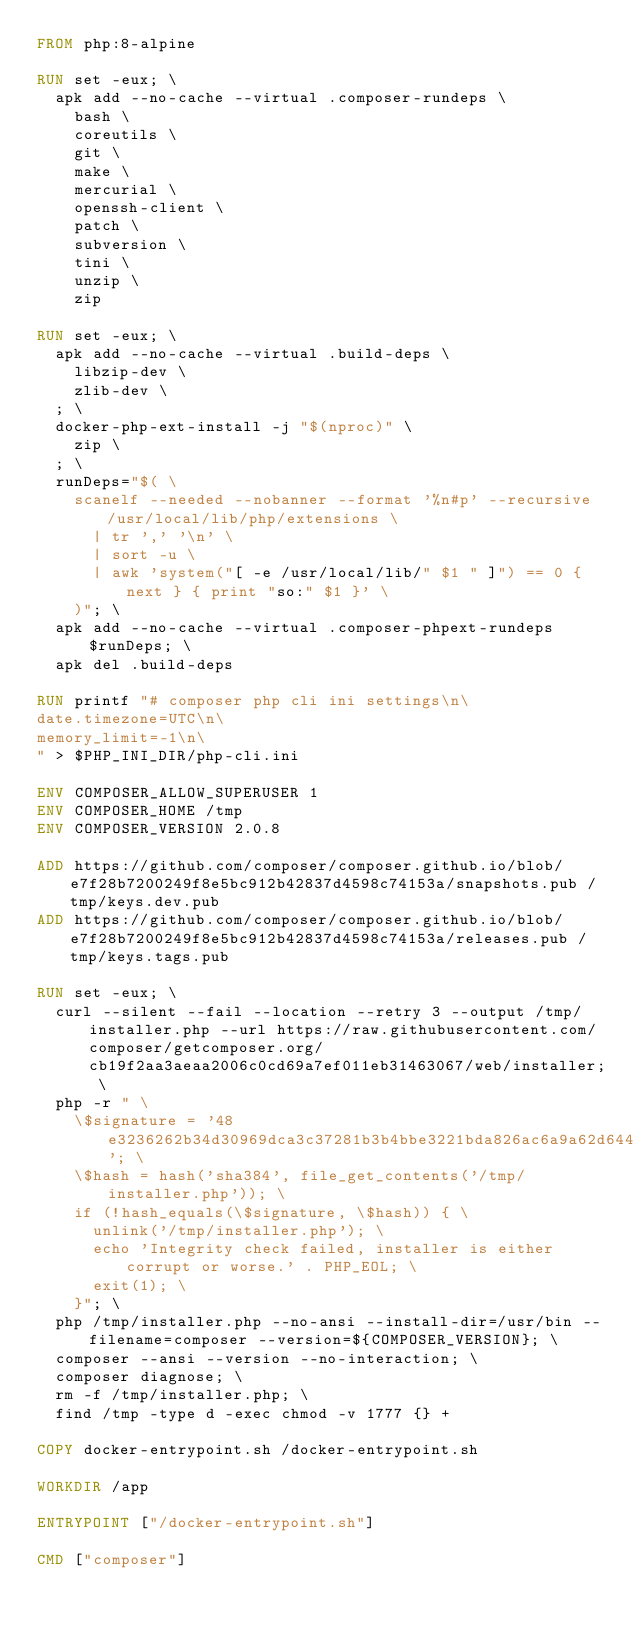Convert code to text. <code><loc_0><loc_0><loc_500><loc_500><_Dockerfile_>FROM php:8-alpine

RUN set -eux; \
  apk add --no-cache --virtual .composer-rundeps \
    bash \
    coreutils \
    git \
    make \
    mercurial \
    openssh-client \
    patch \
    subversion \
    tini \
    unzip \
    zip

RUN set -eux; \
  apk add --no-cache --virtual .build-deps \
    libzip-dev \
    zlib-dev \
  ; \
  docker-php-ext-install -j "$(nproc)" \
    zip \
  ; \
  runDeps="$( \
    scanelf --needed --nobanner --format '%n#p' --recursive /usr/local/lib/php/extensions \
      | tr ',' '\n' \
      | sort -u \
      | awk 'system("[ -e /usr/local/lib/" $1 " ]") == 0 { next } { print "so:" $1 }' \
    )"; \
  apk add --no-cache --virtual .composer-phpext-rundeps $runDeps; \
  apk del .build-deps

RUN printf "# composer php cli ini settings\n\
date.timezone=UTC\n\
memory_limit=-1\n\
" > $PHP_INI_DIR/php-cli.ini

ENV COMPOSER_ALLOW_SUPERUSER 1
ENV COMPOSER_HOME /tmp
ENV COMPOSER_VERSION 2.0.8

ADD https://github.com/composer/composer.github.io/blob/e7f28b7200249f8e5bc912b42837d4598c74153a/snapshots.pub /tmp/keys.dev.pub
ADD https://github.com/composer/composer.github.io/blob/e7f28b7200249f8e5bc912b42837d4598c74153a/releases.pub /tmp/keys.tags.pub

RUN set -eux; \
  curl --silent --fail --location --retry 3 --output /tmp/installer.php --url https://raw.githubusercontent.com/composer/getcomposer.org/cb19f2aa3aeaa2006c0cd69a7ef011eb31463067/web/installer; \
  php -r " \
    \$signature = '48e3236262b34d30969dca3c37281b3b4bbe3221bda826ac6a9a62d6444cdb0dcd0615698a5cbe587c3f0fe57a54d8f5'; \
    \$hash = hash('sha384', file_get_contents('/tmp/installer.php')); \
    if (!hash_equals(\$signature, \$hash)) { \
      unlink('/tmp/installer.php'); \
      echo 'Integrity check failed, installer is either corrupt or worse.' . PHP_EOL; \
      exit(1); \
    }"; \
  php /tmp/installer.php --no-ansi --install-dir=/usr/bin --filename=composer --version=${COMPOSER_VERSION}; \
  composer --ansi --version --no-interaction; \
  composer diagnose; \
  rm -f /tmp/installer.php; \
  find /tmp -type d -exec chmod -v 1777 {} +

COPY docker-entrypoint.sh /docker-entrypoint.sh

WORKDIR /app

ENTRYPOINT ["/docker-entrypoint.sh"]

CMD ["composer"]
</code> 